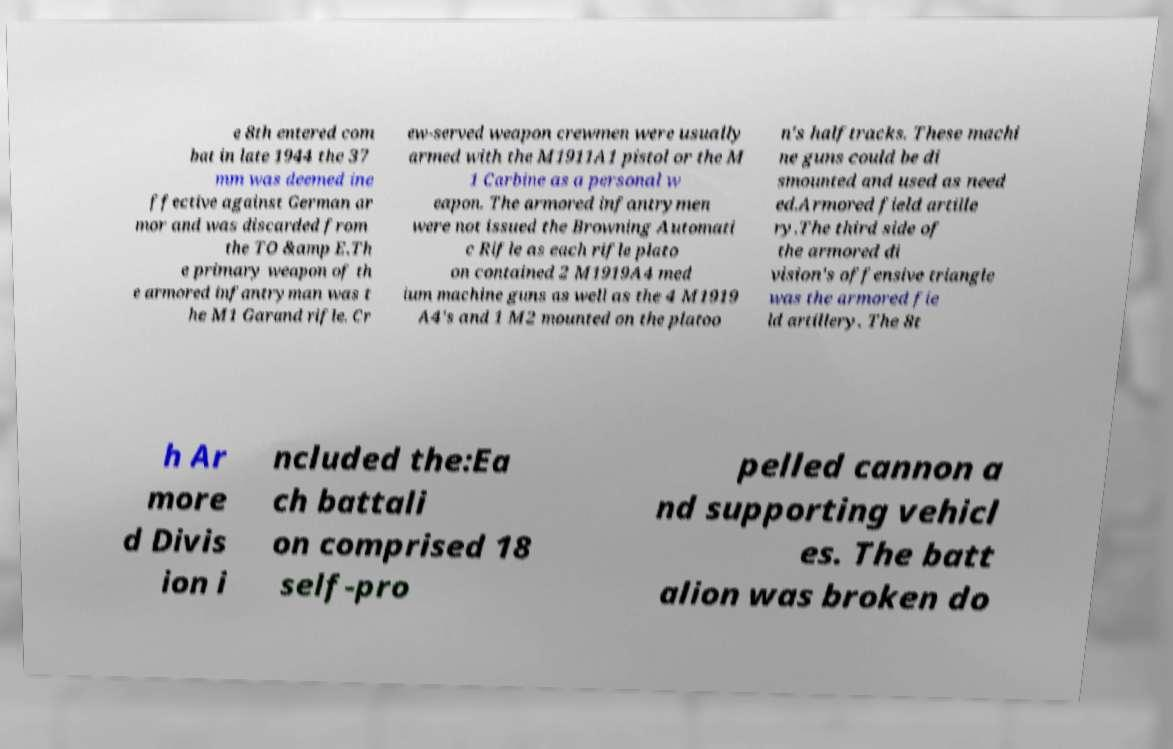There's text embedded in this image that I need extracted. Can you transcribe it verbatim? e 8th entered com bat in late 1944 the 37 mm was deemed ine ffective against German ar mor and was discarded from the TO &amp E.Th e primary weapon of th e armored infantryman was t he M1 Garand rifle. Cr ew-served weapon crewmen were usually armed with the M1911A1 pistol or the M 1 Carbine as a personal w eapon. The armored infantrymen were not issued the Browning Automati c Rifle as each rifle plato on contained 2 M1919A4 med ium machine guns as well as the 4 M1919 A4's and 1 M2 mounted on the platoo n's halftracks. These machi ne guns could be di smounted and used as need ed.Armored field artille ry.The third side of the armored di vision's offensive triangle was the armored fie ld artillery. The 8t h Ar more d Divis ion i ncluded the:Ea ch battali on comprised 18 self-pro pelled cannon a nd supporting vehicl es. The batt alion was broken do 